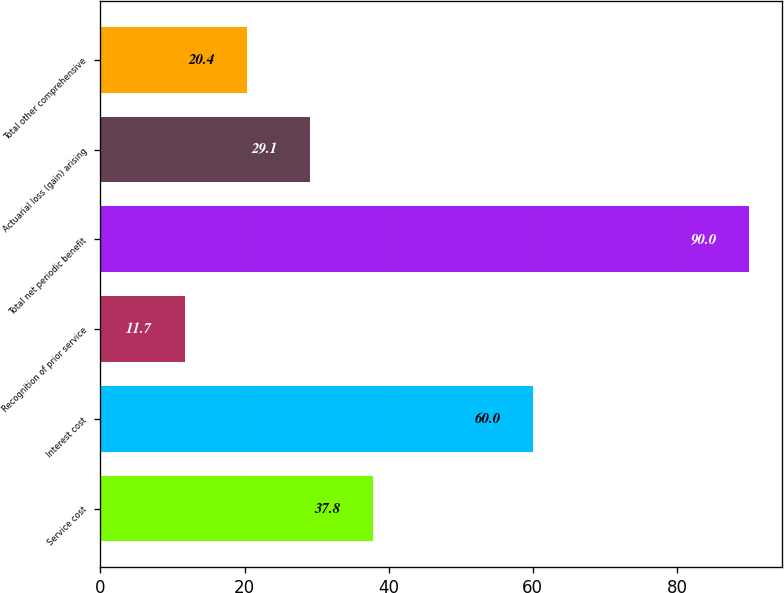<chart> <loc_0><loc_0><loc_500><loc_500><bar_chart><fcel>Service cost<fcel>Interest cost<fcel>Recognition of prior service<fcel>Total net periodic benefit<fcel>Actuarial loss (gain) arising<fcel>Total other comprehensive<nl><fcel>37.8<fcel>60<fcel>11.7<fcel>90<fcel>29.1<fcel>20.4<nl></chart> 